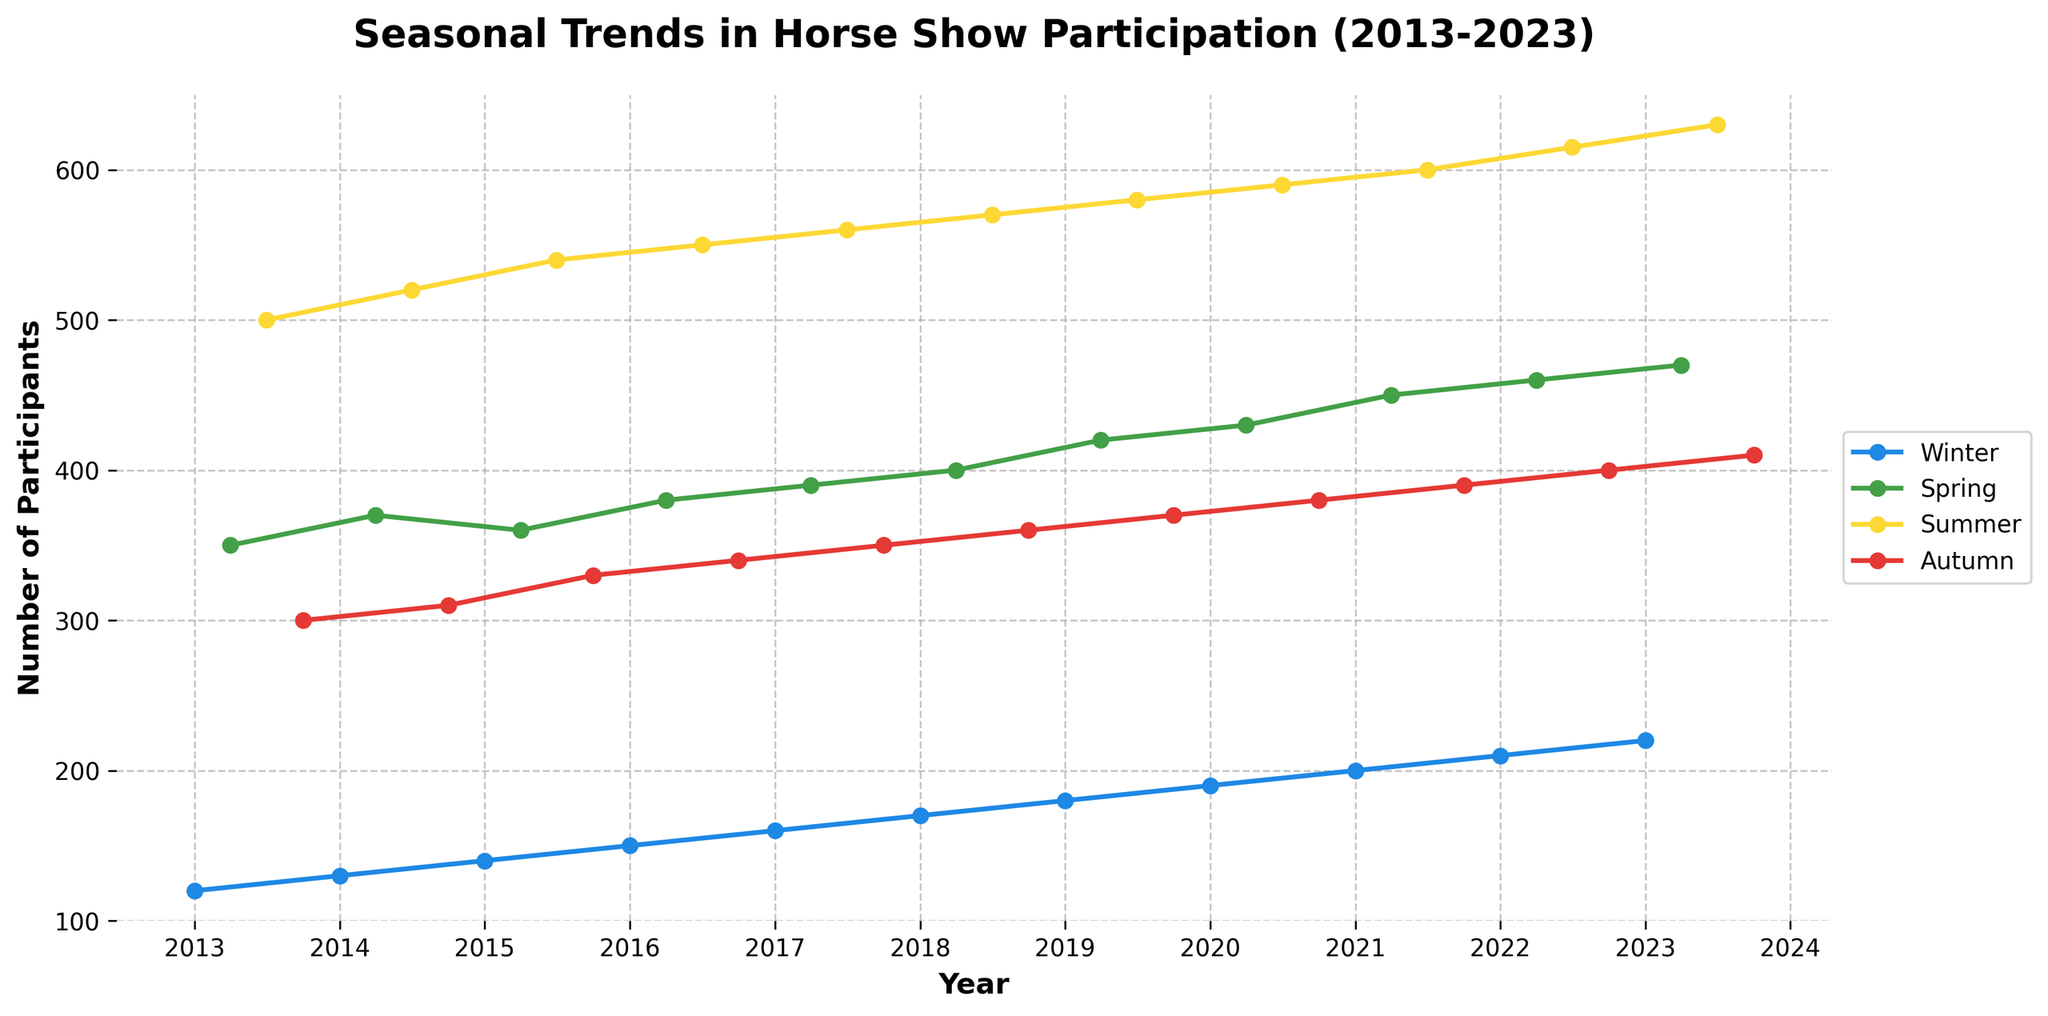what is the general trend in participation over the years for all seasons? To determine the general trend, observe each seasonal line (Winter, Spring, Summer, Autumn). All lines show an upward trajectory from 2013 to 2023, indicating increasing participation across all seasons.
Answer: Increasing Which season has the highest overall participation? Look at the lines and markers for each season; Summer consistently has the highest values throughout the years compared to Winter, Spring, and Autumn.
Answer: Summer In which year did Winter participation reach 200? Find the Winter line and locate the point where the participation equals 200. The data point corresponds to the year 2021.
Answer: 2021 Compare the participation in Spring and Autumn of 2013. Which season had higher participation? Compare the values of Spring and Autumn in 2013. Spring had 350 participants, and Autumn had 300, so Spring had higher participation.
Answer: Spring What is the percentage increase in Summer participation from 2013 to 2023? Summer participation in 2013 was 500, and in 2023 it was 630. The percentage increase is ((630 - 500) / 500) * 100 = 26%.
Answer: 26% How does the participation trend for Spring compare to that of Winter? Observe the trends for Spring and Winter. Both show an increasing trend, but Spring starts at a higher base and increases more consistently compared to Winter.
Answer: Spring shows a more consistent increase Across which years does Autumn show a consistent participation increase? Look at the Autumn line; participation consistently increases from 2013 to 2023, with no dips.
Answer: 2013 to 2023 What is the participation difference between Summer and Winter in 2020? Find the values for Summer and Winter in 2020. Summer is 590, and Winter is 190. The difference is 590 - 190 = 400.
Answer: 400 Which year shows the smallest gap between Spring and Autumn participation? Compare the gaps for Spring and Autumn each year. For 2015, the participation is 360 (Spring) and 330 (Autumn), resulting in the smallest gap of 30.
Answer: 2015 